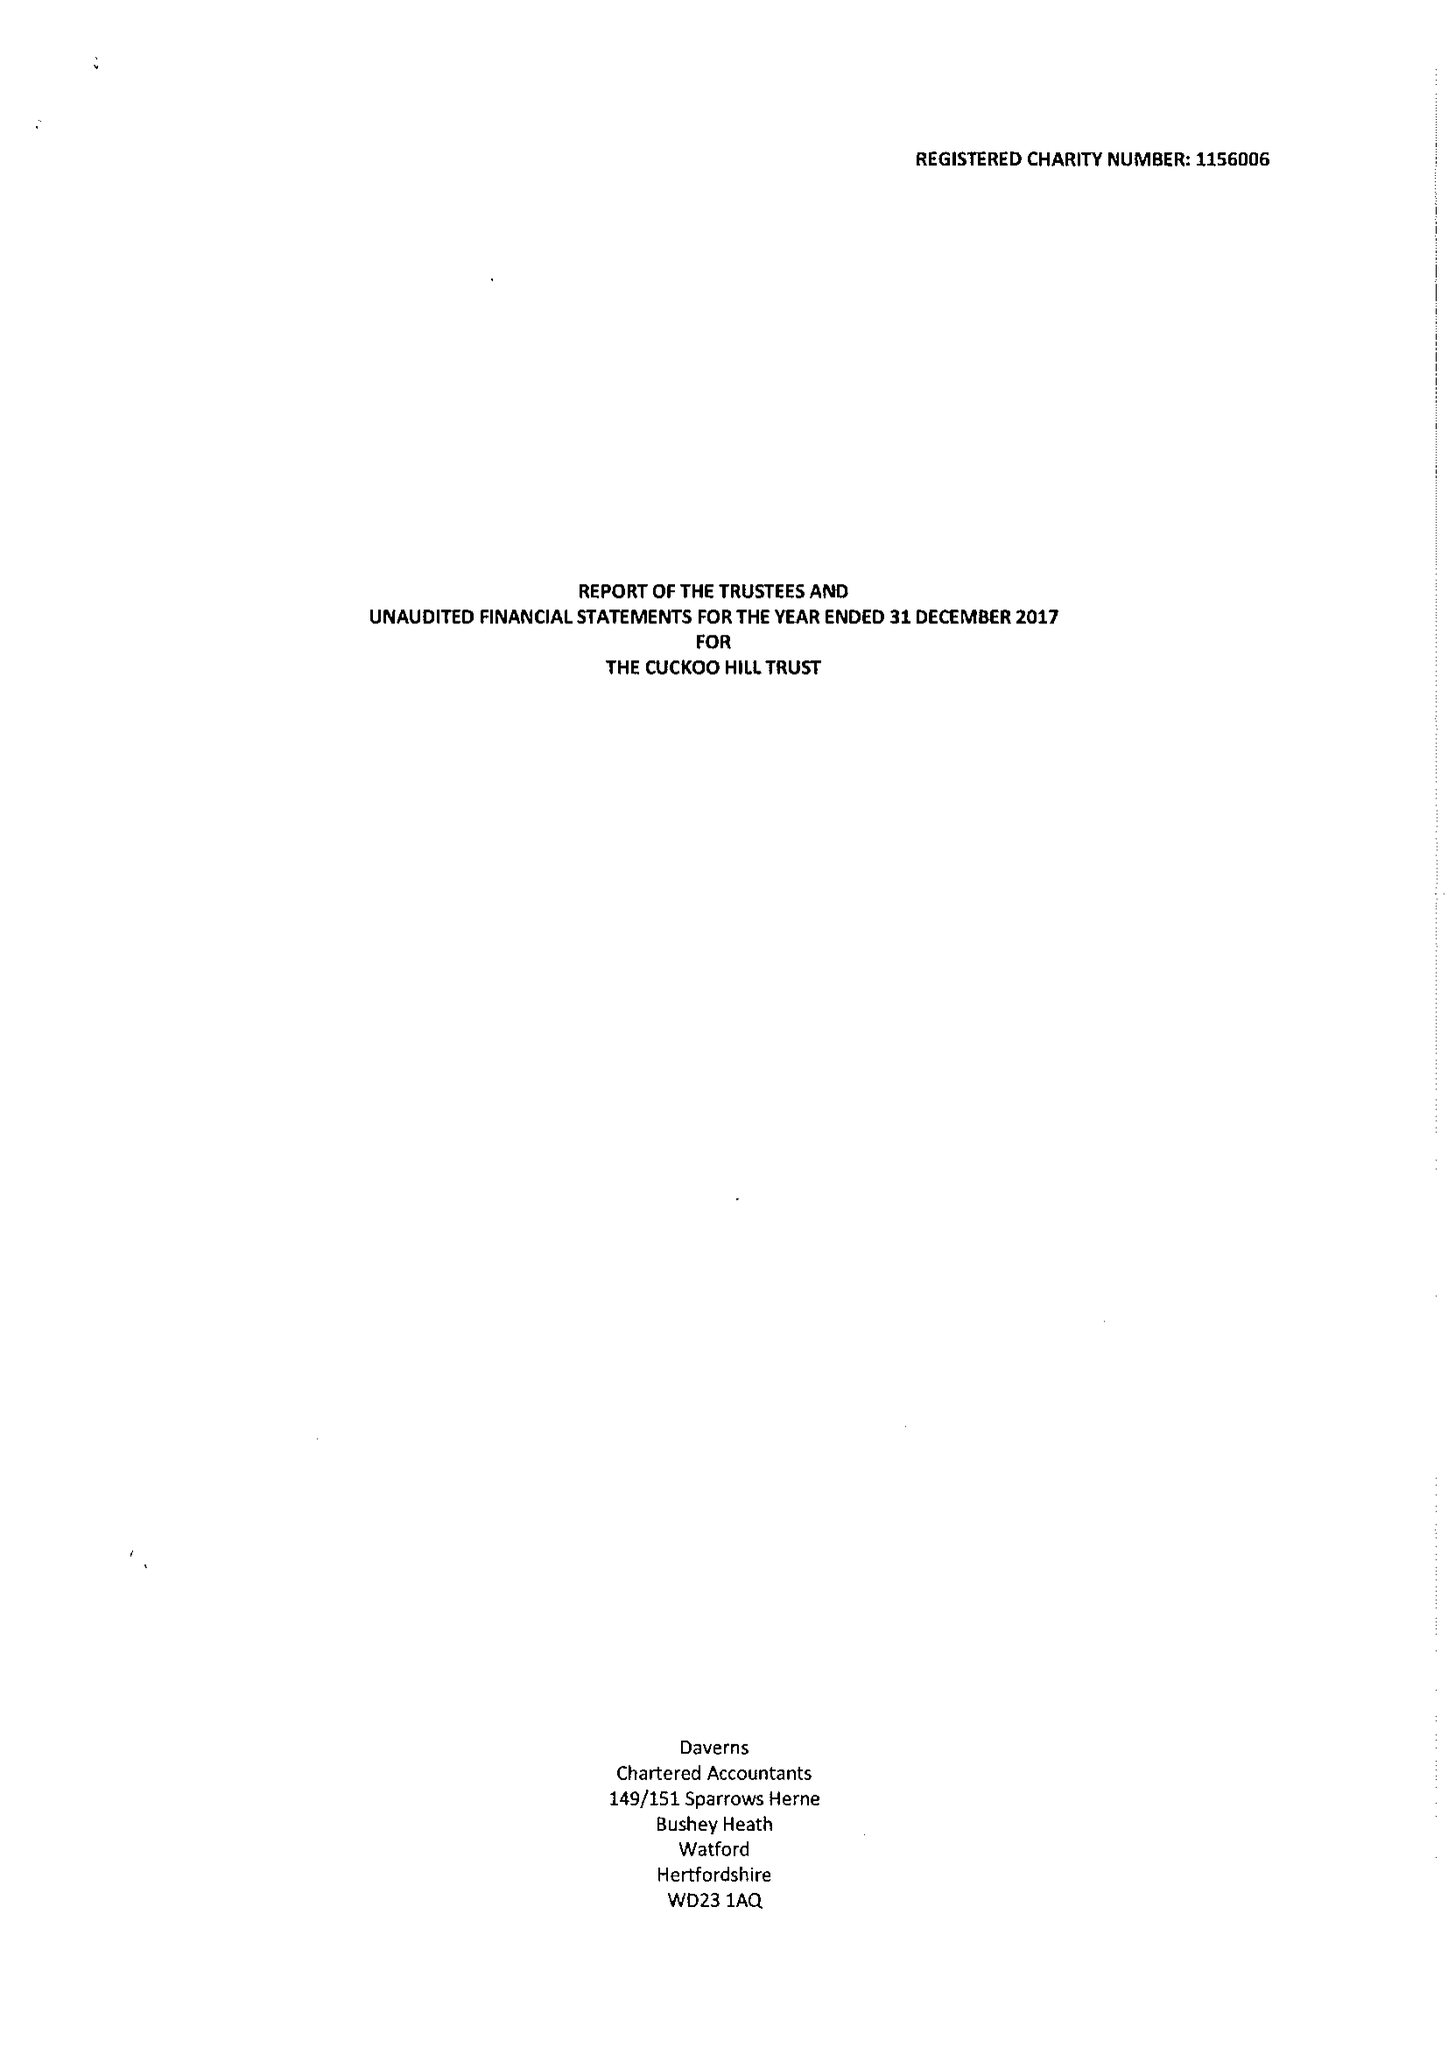What is the value for the address__postcode?
Answer the question using a single word or phrase. HA5 2BB 